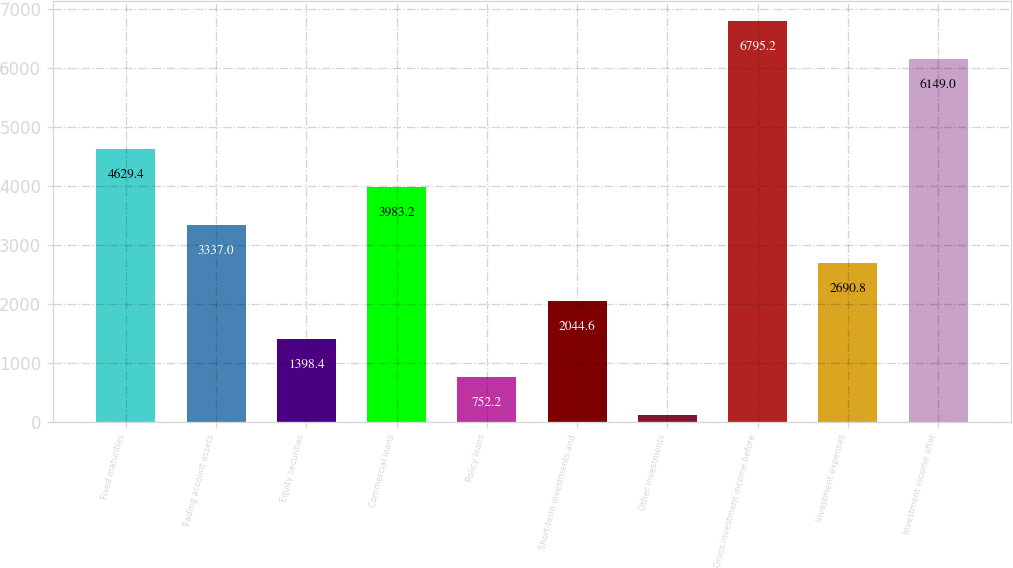<chart> <loc_0><loc_0><loc_500><loc_500><bar_chart><fcel>Fixed maturities<fcel>Trading account assets<fcel>Equity securities<fcel>Commercial loans<fcel>Policy loans<fcel>Short-term investments and<fcel>Other investments<fcel>Gross investment income before<fcel>Investment expenses<fcel>Investment income after<nl><fcel>4629.4<fcel>3337<fcel>1398.4<fcel>3983.2<fcel>752.2<fcel>2044.6<fcel>106<fcel>6795.2<fcel>2690.8<fcel>6149<nl></chart> 